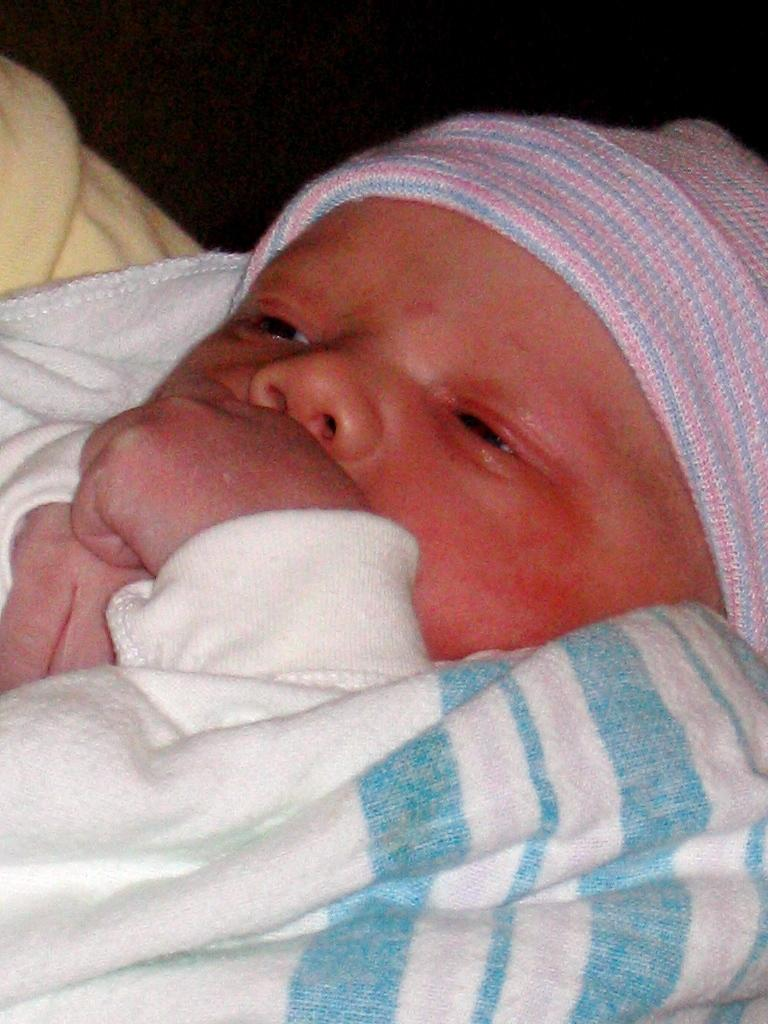What is the main subject of the image? The main subject of the image is a baby. What is the baby wearing on her head? The baby is wearing a cap on her head. What is the amount of amusement the baby is experiencing in the image? There is no indication of the baby's level of amusement in the image. How low is the baby sitting in the image? There is no information about the baby's sitting position in the image. 